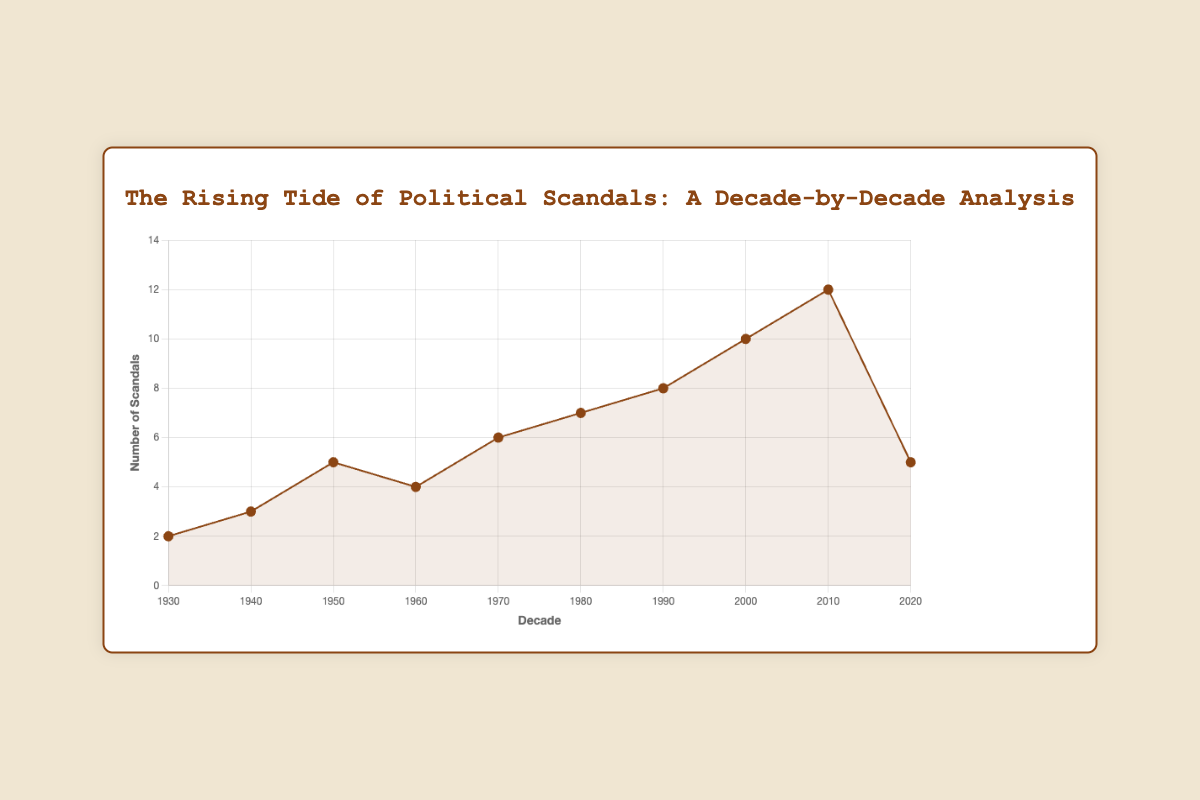How many more political scandals were there in the 2010s compared to the 1930s? First, identify the number of scandals in the 2010s (12) and the 1930s (2). Then, subtract the number of scandals in the 1930s from the number of scandals in the 2010s: 12 - 2 = 10
Answer: 10 Which decade had the most political scandals and how many did it have? Look at the plot to find the peak value. The 2010s show the highest number of scandals, with a total of 12.
Answer: 2010s, 12 How did the number of political scandals change from the 1950s to the 1970s? Compare the number of scandals in the 1950s (5) and the 1970s (6). The number increased by 1.
Answer: Increased by 1 What is the average number of scandals per decade from the 1930s to the 2020s? Sum the number of scandals from each decade: 2 + 3 + 5 + 4 + 6 + 7 + 8 + 10 + 12 + 5 = 62. There are 10 decades. Divide the total by 10: 62 / 10 = 6.2
Answer: 6.2 What trend do you observe in the number of political scandals from the 1930s to the 2010s? Observe the overall shape of the line on the plot. The general trend shows an increase in the number of scandals from the 1930s to the 2010s, peaking in the 2010s.
Answer: Increasing trend Between which two consecutive decades did the number of scandals increase the most? Compare the differences between each consecutive decade and find the largest increase: 1940s to 1950s (5 - 3 = 2), 1970s to 1980s (7 - 6 = 1), and 2000s to 2010s (12 - 10 = 2). The largest increase is between 2000s and 2010s by 2.
Answer: 2000s to 2010s In which decade did the number of political scandals decrease the most compared to the previous decade? Identify the decreases between consecutive decades: 1950s to 1960s (4 - 5 = -1), 2010s to 2020s (5 - 12 = -7). The largest decrease is from the 2010s to the 2020s by 7.
Answer: 2010s to 2020s What is the difference in the number of scandals between the decades with the second-highest and the lowest number of scandals? The second-highest is the 2000s with 10 scandals, and the lowest is the 1930s with 2 scandals. The difference is 10 - 2 = 8.
Answer: 8 How many decades experienced fewer than 5 political scandals? Identify the decades with fewer than 5 scandals: 1930s (2), 1940s (3), and 1960s (4). There are 3 such decades.
Answer: 3 